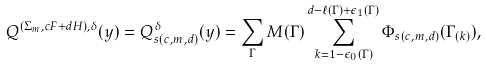Convert formula to latex. <formula><loc_0><loc_0><loc_500><loc_500>Q ^ { ( \Sigma _ { m } , c F + d H ) , \delta } ( y ) = Q ^ { \delta } _ { s ( c , m , d ) } ( y ) = \sum _ { \Gamma } M ( \Gamma ) \sum _ { k = 1 - \epsilon _ { 0 } ( \Gamma ) } ^ { d - \ell ( \Gamma ) + \epsilon _ { 1 } ( \Gamma ) } \Phi _ { s ( c , m , d ) } ( \Gamma _ { ( k ) } ) ,</formula> 